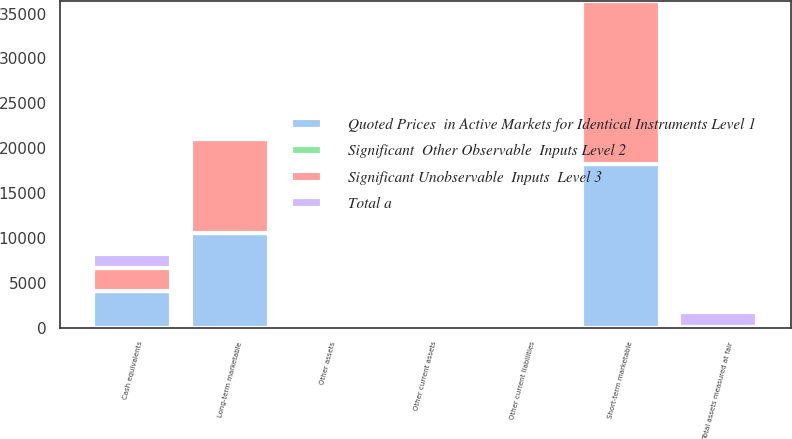Convert chart. <chart><loc_0><loc_0><loc_500><loc_500><stacked_bar_chart><ecel><fcel>Cash equivalents<fcel>Short-term marketable<fcel>Long-term marketable<fcel>Other current assets<fcel>Other assets<fcel>Total assets measured at fair<fcel>Other current liabilities<nl><fcel>Total a<fcel>1608<fcel>0<fcel>0<fcel>0<fcel>61<fcel>1669<fcel>0<nl><fcel>Significant Unobservable  Inputs  Level 3<fcel>2516<fcel>18201<fcel>10528<fcel>37<fcel>0<fcel>25<fcel>25<nl><fcel>Significant  Other Observable  Inputs Level 2<fcel>0<fcel>0<fcel>0<fcel>0<fcel>0<fcel>0<fcel>0<nl><fcel>Quoted Prices  in Active Markets for Identical Instruments Level 1<fcel>4124<fcel>18201<fcel>10528<fcel>37<fcel>61<fcel>25<fcel>25<nl></chart> 